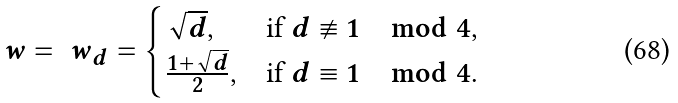<formula> <loc_0><loc_0><loc_500><loc_500>\ w = \ w _ { d } = \begin{cases} \sqrt { d } , & \text {if $d\not\equiv 1 \mod 4$} , \\ \frac { 1 + \sqrt { d } } { 2 } , & \text {if $d\equiv 1\mod 4$} . \end{cases}</formula> 